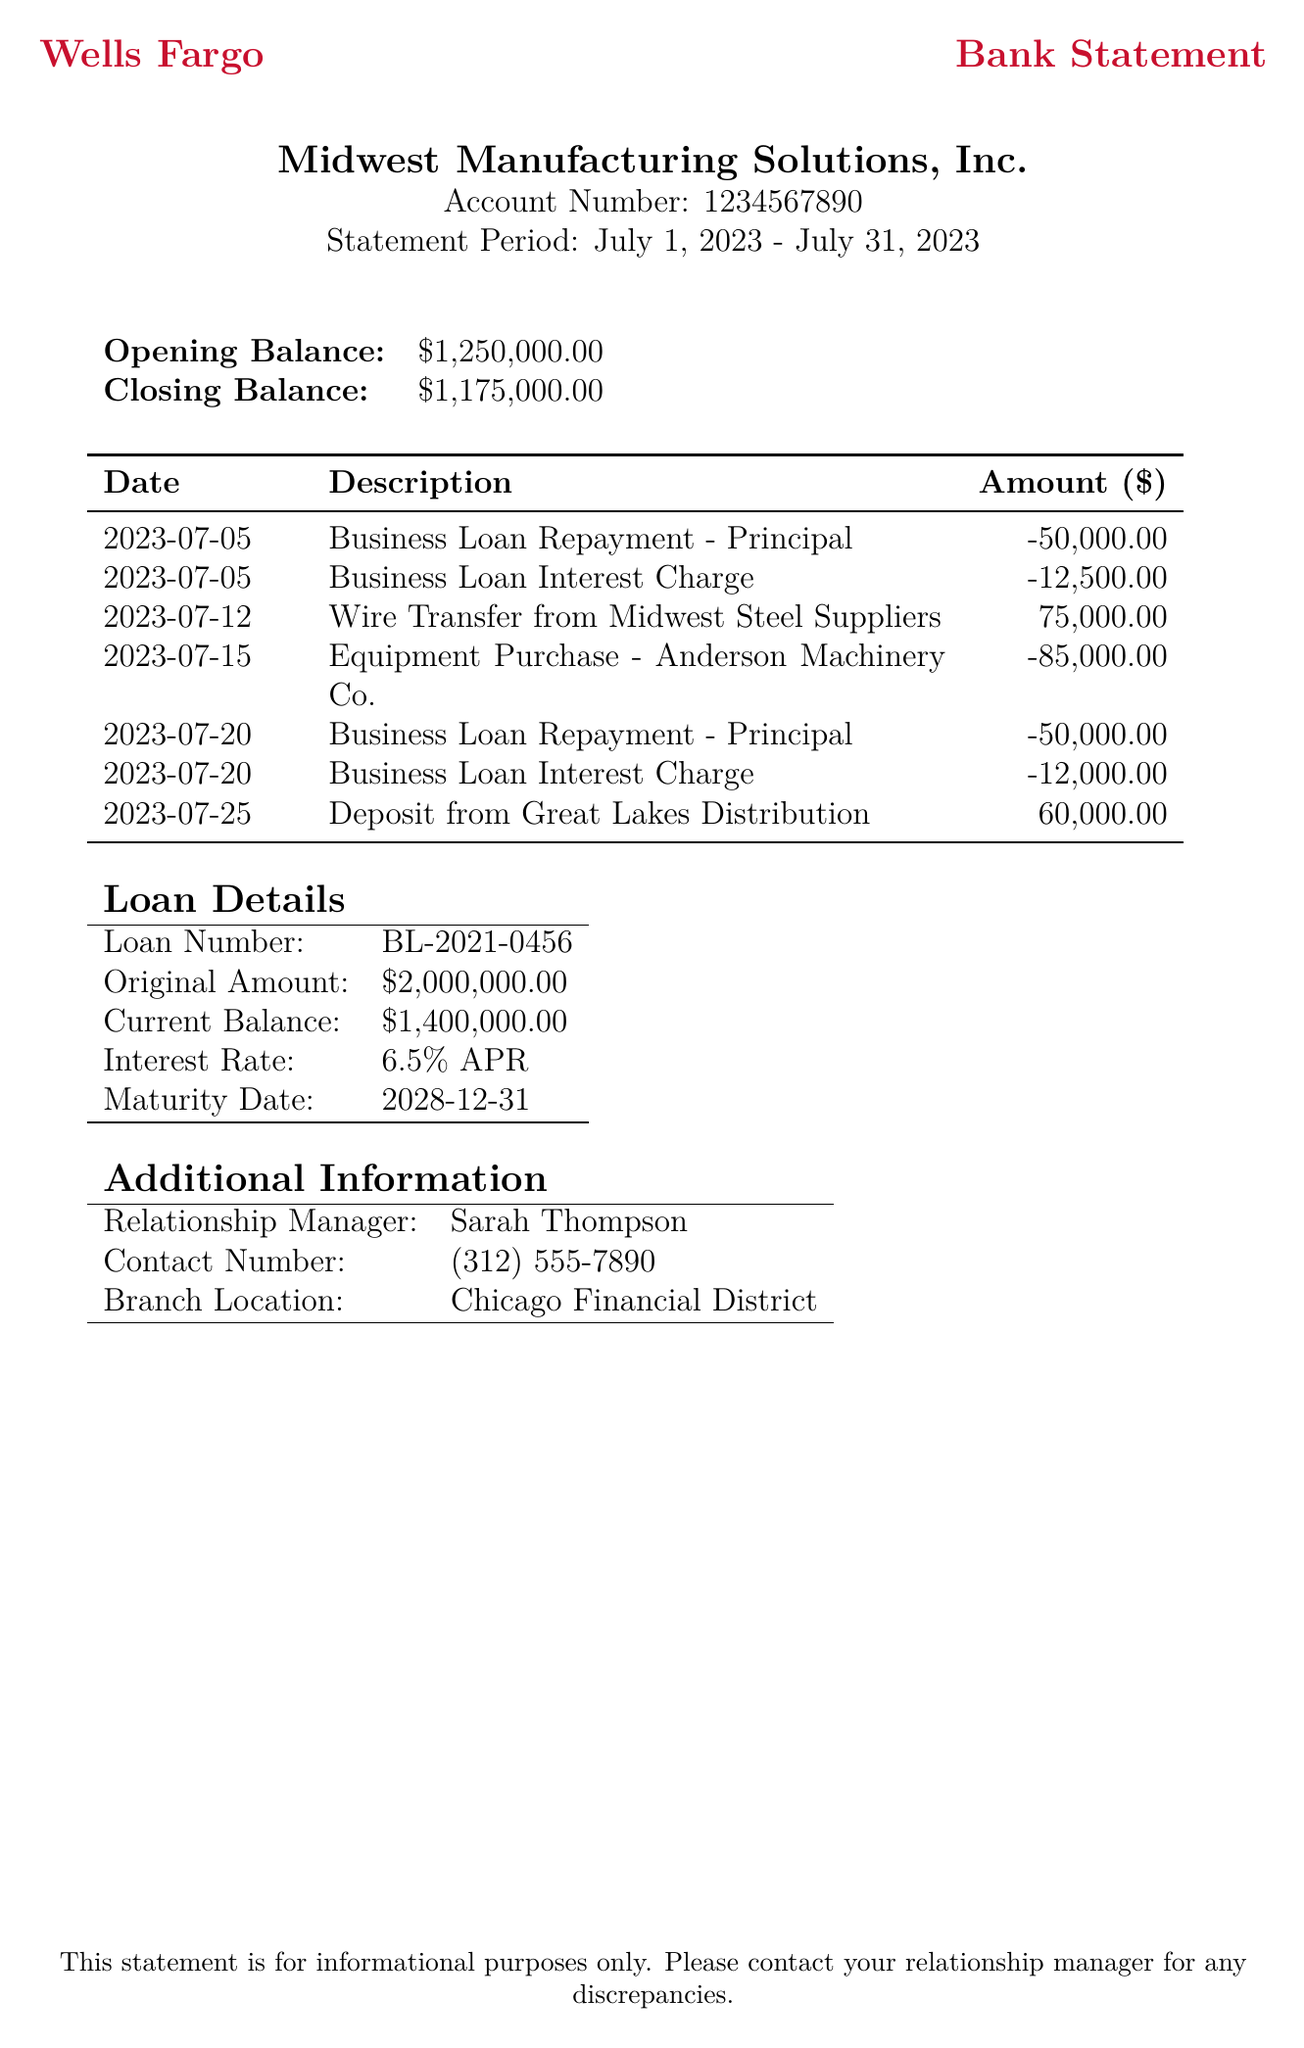What is the bank name? The bank name is presented in the header of the document, which is Wells Fargo.
Answer: Wells Fargo What is the account holder's name? The account holder's name is stated at the top of the document.
Answer: Midwest Manufacturing Solutions, Inc What is the statement period? The statement period is provided in the heading section of the document as a date range.
Answer: July 1, 2023 - July 31, 2023 How much was the principal paid back on July 5? Referring to the transactions, the amount for the principal repayment on this date is specified as a negative value.
Answer: 50000.00 What is the total interest charge for the month? The total interest charges can be summed from the specified transaction dates and amounts.
Answer: 24500.00 What is the current balance of the loan? This information is found under the loan details section of the document.
Answer: 1400000.00 Who is the relationship manager? The name of the relationship manager is listed under the additional information section.
Answer: Sarah Thompson When is the maturity date of the loan? The maturity date can be found in the loan details section of the document.
Answer: 2028-12-31 How much was the equipment purchased for? This can be found in the transaction list, noting the date and description of the purchase.
Answer: 85000.00 